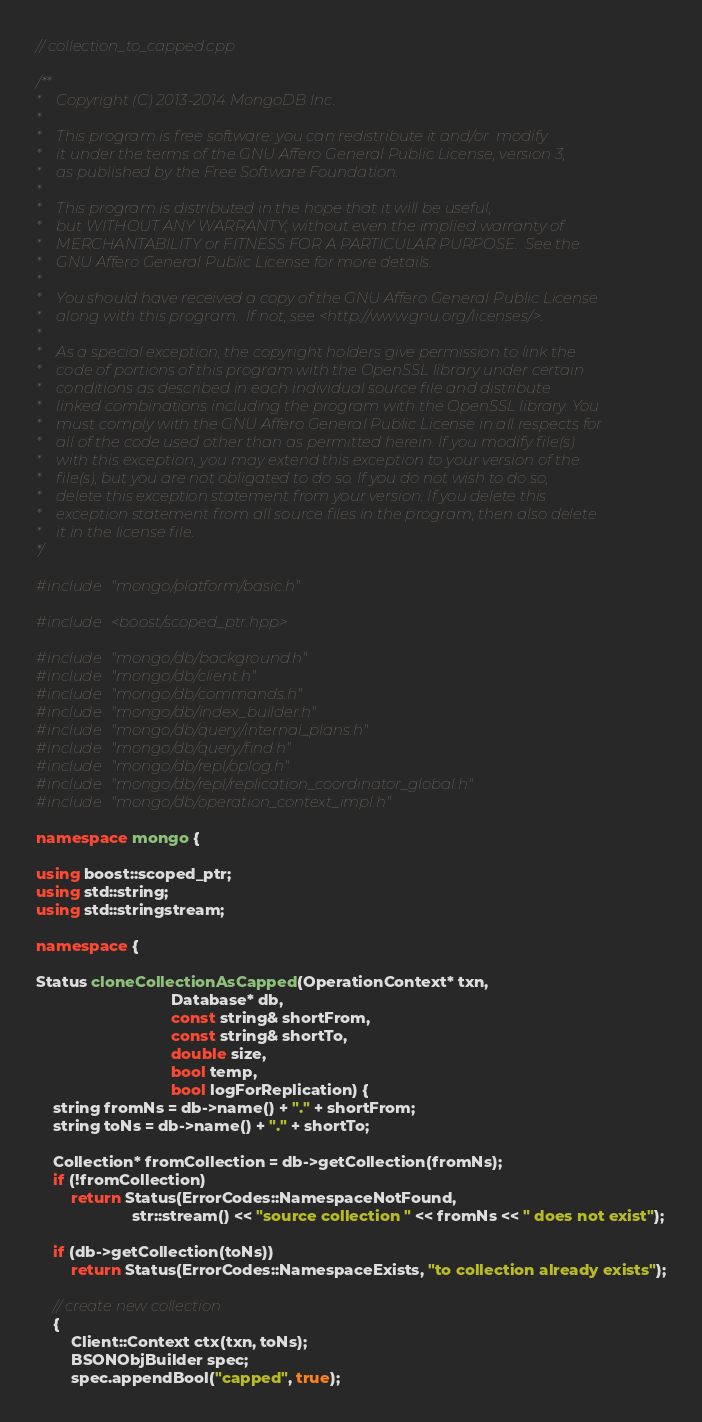Convert code to text. <code><loc_0><loc_0><loc_500><loc_500><_C++_>// collection_to_capped.cpp

/**
*    Copyright (C) 2013-2014 MongoDB Inc.
*
*    This program is free software: you can redistribute it and/or  modify
*    it under the terms of the GNU Affero General Public License, version 3,
*    as published by the Free Software Foundation.
*
*    This program is distributed in the hope that it will be useful,
*    but WITHOUT ANY WARRANTY; without even the implied warranty of
*    MERCHANTABILITY or FITNESS FOR A PARTICULAR PURPOSE.  See the
*    GNU Affero General Public License for more details.
*
*    You should have received a copy of the GNU Affero General Public License
*    along with this program.  If not, see <http://www.gnu.org/licenses/>.
*
*    As a special exception, the copyright holders give permission to link the
*    code of portions of this program with the OpenSSL library under certain
*    conditions as described in each individual source file and distribute
*    linked combinations including the program with the OpenSSL library. You
*    must comply with the GNU Affero General Public License in all respects for
*    all of the code used other than as permitted herein. If you modify file(s)
*    with this exception, you may extend this exception to your version of the
*    file(s), but you are not obligated to do so. If you do not wish to do so,
*    delete this exception statement from your version. If you delete this
*    exception statement from all source files in the program, then also delete
*    it in the license file.
*/

#include "mongo/platform/basic.h"

#include <boost/scoped_ptr.hpp>

#include "mongo/db/background.h"
#include "mongo/db/client.h"
#include "mongo/db/commands.h"
#include "mongo/db/index_builder.h"
#include "mongo/db/query/internal_plans.h"
#include "mongo/db/query/find.h"
#include "mongo/db/repl/oplog.h"
#include "mongo/db/repl/replication_coordinator_global.h"
#include "mongo/db/operation_context_impl.h"

namespace mongo {

using boost::scoped_ptr;
using std::string;
using std::stringstream;

namespace {

Status cloneCollectionAsCapped(OperationContext* txn,
                               Database* db,
                               const string& shortFrom,
                               const string& shortTo,
                               double size,
                               bool temp,
                               bool logForReplication) {
    string fromNs = db->name() + "." + shortFrom;
    string toNs = db->name() + "." + shortTo;

    Collection* fromCollection = db->getCollection(fromNs);
    if (!fromCollection)
        return Status(ErrorCodes::NamespaceNotFound,
                      str::stream() << "source collection " << fromNs << " does not exist");

    if (db->getCollection(toNs))
        return Status(ErrorCodes::NamespaceExists, "to collection already exists");

    // create new collection
    {
        Client::Context ctx(txn, toNs);
        BSONObjBuilder spec;
        spec.appendBool("capped", true);</code> 